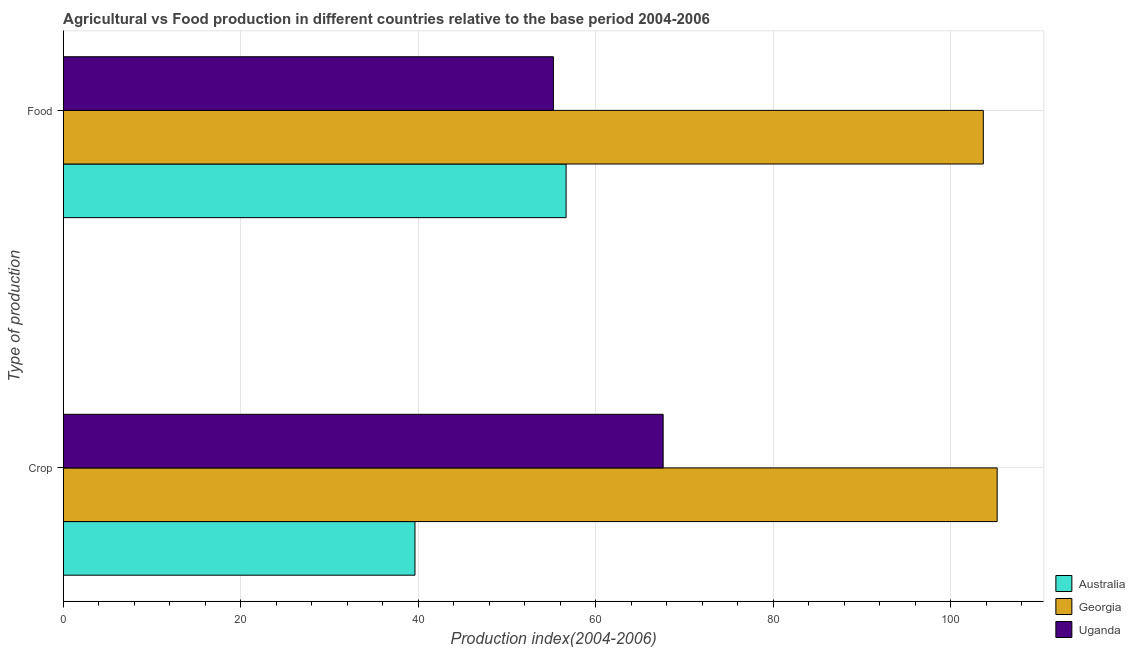How many bars are there on the 1st tick from the top?
Your answer should be very brief. 3. What is the label of the 1st group of bars from the top?
Provide a succinct answer. Food. What is the food production index in Australia?
Make the answer very short. 56.67. Across all countries, what is the maximum food production index?
Make the answer very short. 103.69. Across all countries, what is the minimum food production index?
Keep it short and to the point. 55.24. In which country was the crop production index maximum?
Give a very brief answer. Georgia. In which country was the food production index minimum?
Your answer should be compact. Uganda. What is the total food production index in the graph?
Offer a very short reply. 215.6. What is the difference between the food production index in Uganda and that in Australia?
Ensure brevity in your answer.  -1.43. What is the difference between the crop production index in Georgia and the food production index in Uganda?
Your response must be concise. 50.01. What is the average crop production index per country?
Keep it short and to the point. 70.83. What is the difference between the food production index and crop production index in Georgia?
Ensure brevity in your answer.  -1.56. In how many countries, is the food production index greater than 16 ?
Make the answer very short. 3. What is the ratio of the food production index in Uganda to that in Georgia?
Your response must be concise. 0.53. Is the crop production index in Uganda less than that in Georgia?
Give a very brief answer. Yes. What does the 3rd bar from the top in Food represents?
Offer a terse response. Australia. What does the 1st bar from the bottom in Crop represents?
Ensure brevity in your answer.  Australia. How many bars are there?
Your answer should be compact. 6. How many countries are there in the graph?
Your answer should be compact. 3. Are the values on the major ticks of X-axis written in scientific E-notation?
Give a very brief answer. No. Does the graph contain any zero values?
Your response must be concise. No. How are the legend labels stacked?
Provide a short and direct response. Vertical. What is the title of the graph?
Provide a short and direct response. Agricultural vs Food production in different countries relative to the base period 2004-2006. What is the label or title of the X-axis?
Your answer should be compact. Production index(2004-2006). What is the label or title of the Y-axis?
Offer a terse response. Type of production. What is the Production index(2004-2006) in Australia in Crop?
Give a very brief answer. 39.64. What is the Production index(2004-2006) of Georgia in Crop?
Offer a very short reply. 105.25. What is the Production index(2004-2006) of Uganda in Crop?
Your answer should be compact. 67.61. What is the Production index(2004-2006) of Australia in Food?
Provide a succinct answer. 56.67. What is the Production index(2004-2006) in Georgia in Food?
Your response must be concise. 103.69. What is the Production index(2004-2006) in Uganda in Food?
Ensure brevity in your answer.  55.24. Across all Type of production, what is the maximum Production index(2004-2006) in Australia?
Offer a very short reply. 56.67. Across all Type of production, what is the maximum Production index(2004-2006) of Georgia?
Provide a succinct answer. 105.25. Across all Type of production, what is the maximum Production index(2004-2006) of Uganda?
Make the answer very short. 67.61. Across all Type of production, what is the minimum Production index(2004-2006) of Australia?
Keep it short and to the point. 39.64. Across all Type of production, what is the minimum Production index(2004-2006) of Georgia?
Offer a very short reply. 103.69. Across all Type of production, what is the minimum Production index(2004-2006) in Uganda?
Your answer should be very brief. 55.24. What is the total Production index(2004-2006) in Australia in the graph?
Give a very brief answer. 96.31. What is the total Production index(2004-2006) of Georgia in the graph?
Offer a terse response. 208.94. What is the total Production index(2004-2006) of Uganda in the graph?
Your answer should be compact. 122.85. What is the difference between the Production index(2004-2006) of Australia in Crop and that in Food?
Offer a very short reply. -17.03. What is the difference between the Production index(2004-2006) in Georgia in Crop and that in Food?
Keep it short and to the point. 1.56. What is the difference between the Production index(2004-2006) of Uganda in Crop and that in Food?
Your response must be concise. 12.37. What is the difference between the Production index(2004-2006) of Australia in Crop and the Production index(2004-2006) of Georgia in Food?
Make the answer very short. -64.05. What is the difference between the Production index(2004-2006) of Australia in Crop and the Production index(2004-2006) of Uganda in Food?
Offer a very short reply. -15.6. What is the difference between the Production index(2004-2006) of Georgia in Crop and the Production index(2004-2006) of Uganda in Food?
Your response must be concise. 50.01. What is the average Production index(2004-2006) of Australia per Type of production?
Offer a very short reply. 48.16. What is the average Production index(2004-2006) of Georgia per Type of production?
Your answer should be very brief. 104.47. What is the average Production index(2004-2006) in Uganda per Type of production?
Offer a terse response. 61.42. What is the difference between the Production index(2004-2006) in Australia and Production index(2004-2006) in Georgia in Crop?
Offer a very short reply. -65.61. What is the difference between the Production index(2004-2006) in Australia and Production index(2004-2006) in Uganda in Crop?
Ensure brevity in your answer.  -27.97. What is the difference between the Production index(2004-2006) in Georgia and Production index(2004-2006) in Uganda in Crop?
Your answer should be very brief. 37.64. What is the difference between the Production index(2004-2006) in Australia and Production index(2004-2006) in Georgia in Food?
Your answer should be very brief. -47.02. What is the difference between the Production index(2004-2006) of Australia and Production index(2004-2006) of Uganda in Food?
Offer a very short reply. 1.43. What is the difference between the Production index(2004-2006) in Georgia and Production index(2004-2006) in Uganda in Food?
Offer a terse response. 48.45. What is the ratio of the Production index(2004-2006) in Australia in Crop to that in Food?
Your response must be concise. 0.7. What is the ratio of the Production index(2004-2006) in Georgia in Crop to that in Food?
Offer a terse response. 1.01. What is the ratio of the Production index(2004-2006) of Uganda in Crop to that in Food?
Offer a very short reply. 1.22. What is the difference between the highest and the second highest Production index(2004-2006) of Australia?
Your answer should be very brief. 17.03. What is the difference between the highest and the second highest Production index(2004-2006) in Georgia?
Offer a very short reply. 1.56. What is the difference between the highest and the second highest Production index(2004-2006) in Uganda?
Offer a terse response. 12.37. What is the difference between the highest and the lowest Production index(2004-2006) of Australia?
Your answer should be very brief. 17.03. What is the difference between the highest and the lowest Production index(2004-2006) in Georgia?
Provide a short and direct response. 1.56. What is the difference between the highest and the lowest Production index(2004-2006) in Uganda?
Make the answer very short. 12.37. 